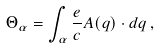<formula> <loc_0><loc_0><loc_500><loc_500>\Theta _ { \alpha } = \int _ { \alpha } \frac { e } { c } { A } ( { q } ) \cdot d { q } \, ,</formula> 